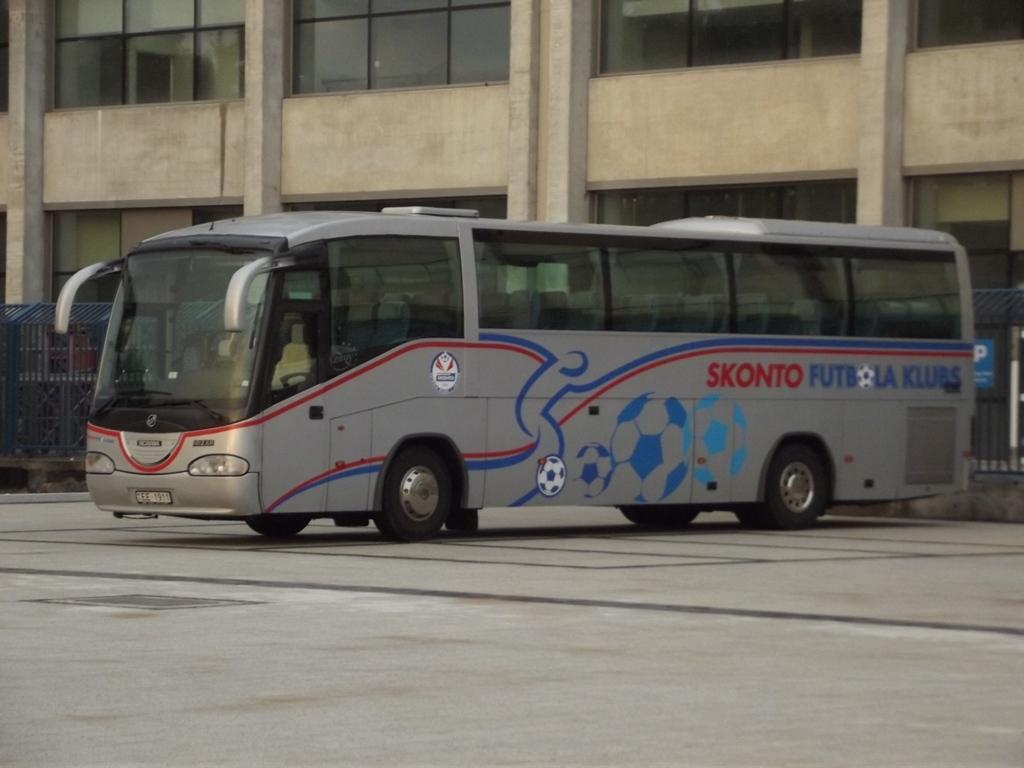Could you give a brief overview of what you see in this image? In this image we can see a motor vehicle on the road, fences and building. 